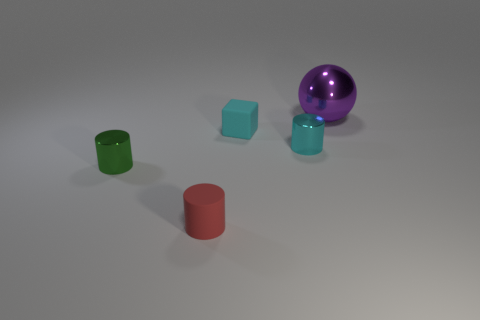Subtract 1 cylinders. How many cylinders are left? 2 Add 4 big purple spheres. How many objects exist? 9 Subtract all cylinders. How many objects are left? 2 Subtract all large things. Subtract all small cyan matte things. How many objects are left? 3 Add 3 tiny objects. How many tiny objects are left? 7 Add 1 large purple shiny spheres. How many large purple shiny spheres exist? 2 Subtract 0 purple cubes. How many objects are left? 5 